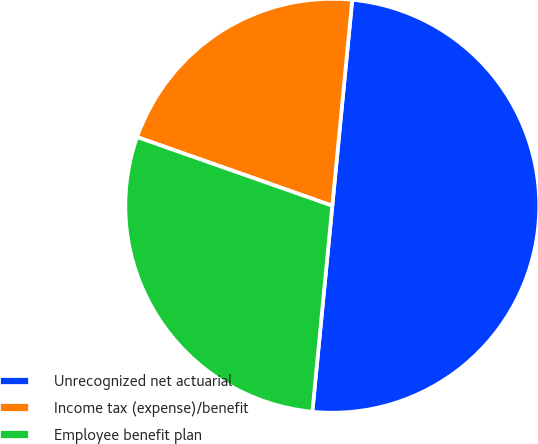Convert chart. <chart><loc_0><loc_0><loc_500><loc_500><pie_chart><fcel>Unrecognized net actuarial<fcel>Income tax (expense)/benefit<fcel>Employee benefit plan<nl><fcel>50.0%<fcel>21.15%<fcel>28.85%<nl></chart> 